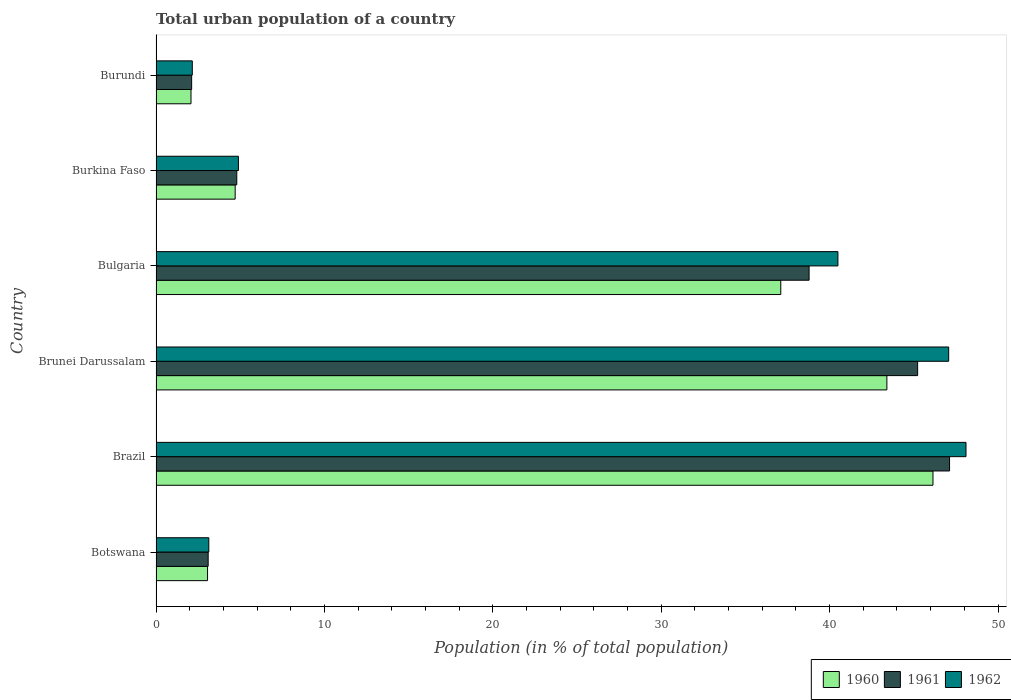Are the number of bars per tick equal to the number of legend labels?
Make the answer very short. Yes. What is the label of the 2nd group of bars from the top?
Provide a short and direct response. Burkina Faso. In how many cases, is the number of bars for a given country not equal to the number of legend labels?
Provide a succinct answer. 0. What is the urban population in 1962 in Burkina Faso?
Keep it short and to the point. 4.89. Across all countries, what is the maximum urban population in 1960?
Ensure brevity in your answer.  46.14. Across all countries, what is the minimum urban population in 1960?
Give a very brief answer. 2.08. In which country was the urban population in 1961 maximum?
Make the answer very short. Brazil. In which country was the urban population in 1960 minimum?
Your answer should be compact. Burundi. What is the total urban population in 1961 in the graph?
Your answer should be compact. 141.14. What is the difference between the urban population in 1962 in Brazil and that in Burkina Faso?
Give a very brief answer. 43.21. What is the difference between the urban population in 1961 in Brunei Darussalam and the urban population in 1960 in Bulgaria?
Your answer should be compact. 8.13. What is the average urban population in 1960 per country?
Offer a very short reply. 22.75. What is the difference between the urban population in 1961 and urban population in 1960 in Brazil?
Offer a very short reply. 0.98. What is the ratio of the urban population in 1960 in Brazil to that in Burkina Faso?
Make the answer very short. 9.82. Is the urban population in 1961 in Bulgaria less than that in Burkina Faso?
Make the answer very short. No. Is the difference between the urban population in 1961 in Brunei Darussalam and Bulgaria greater than the difference between the urban population in 1960 in Brunei Darussalam and Bulgaria?
Offer a very short reply. Yes. What is the difference between the highest and the second highest urban population in 1960?
Offer a very short reply. 2.74. What is the difference between the highest and the lowest urban population in 1961?
Your answer should be very brief. 45.01. In how many countries, is the urban population in 1962 greater than the average urban population in 1962 taken over all countries?
Ensure brevity in your answer.  3. Is it the case that in every country, the sum of the urban population in 1960 and urban population in 1961 is greater than the urban population in 1962?
Your answer should be very brief. Yes. How many bars are there?
Provide a short and direct response. 18. How many countries are there in the graph?
Your answer should be compact. 6. What is the difference between two consecutive major ticks on the X-axis?
Provide a short and direct response. 10. Does the graph contain any zero values?
Your response must be concise. No. Where does the legend appear in the graph?
Your answer should be very brief. Bottom right. How many legend labels are there?
Your response must be concise. 3. How are the legend labels stacked?
Your response must be concise. Horizontal. What is the title of the graph?
Your answer should be very brief. Total urban population of a country. What is the label or title of the X-axis?
Your answer should be very brief. Population (in % of total population). What is the label or title of the Y-axis?
Offer a very short reply. Country. What is the Population (in % of total population) of 1960 in Botswana?
Your answer should be compact. 3.06. What is the Population (in % of total population) in 1961 in Botswana?
Your answer should be very brief. 3.1. What is the Population (in % of total population) in 1962 in Botswana?
Offer a very short reply. 3.13. What is the Population (in % of total population) of 1960 in Brazil?
Provide a short and direct response. 46.14. What is the Population (in % of total population) of 1961 in Brazil?
Your response must be concise. 47.12. What is the Population (in % of total population) of 1962 in Brazil?
Offer a very short reply. 48.1. What is the Population (in % of total population) in 1960 in Brunei Darussalam?
Keep it short and to the point. 43.4. What is the Population (in % of total population) of 1961 in Brunei Darussalam?
Your response must be concise. 45.23. What is the Population (in % of total population) of 1962 in Brunei Darussalam?
Offer a terse response. 47.07. What is the Population (in % of total population) of 1960 in Bulgaria?
Give a very brief answer. 37.1. What is the Population (in % of total population) in 1961 in Bulgaria?
Provide a short and direct response. 38.78. What is the Population (in % of total population) in 1962 in Bulgaria?
Give a very brief answer. 40.49. What is the Population (in % of total population) in 1961 in Burkina Faso?
Make the answer very short. 4.8. What is the Population (in % of total population) of 1962 in Burkina Faso?
Make the answer very short. 4.89. What is the Population (in % of total population) of 1960 in Burundi?
Provide a succinct answer. 2.08. What is the Population (in % of total population) of 1961 in Burundi?
Make the answer very short. 2.12. What is the Population (in % of total population) of 1962 in Burundi?
Offer a terse response. 2.15. Across all countries, what is the maximum Population (in % of total population) of 1960?
Offer a terse response. 46.14. Across all countries, what is the maximum Population (in % of total population) in 1961?
Keep it short and to the point. 47.12. Across all countries, what is the maximum Population (in % of total population) of 1962?
Offer a very short reply. 48.1. Across all countries, what is the minimum Population (in % of total population) in 1960?
Make the answer very short. 2.08. Across all countries, what is the minimum Population (in % of total population) in 1961?
Make the answer very short. 2.12. Across all countries, what is the minimum Population (in % of total population) in 1962?
Offer a terse response. 2.15. What is the total Population (in % of total population) in 1960 in the graph?
Offer a terse response. 136.48. What is the total Population (in % of total population) in 1961 in the graph?
Your answer should be very brief. 141.14. What is the total Population (in % of total population) of 1962 in the graph?
Provide a succinct answer. 145.84. What is the difference between the Population (in % of total population) in 1960 in Botswana and that in Brazil?
Keep it short and to the point. -43.08. What is the difference between the Population (in % of total population) of 1961 in Botswana and that in Brazil?
Ensure brevity in your answer.  -44.02. What is the difference between the Population (in % of total population) in 1962 in Botswana and that in Brazil?
Your answer should be very brief. -44.97. What is the difference between the Population (in % of total population) in 1960 in Botswana and that in Brunei Darussalam?
Give a very brief answer. -40.34. What is the difference between the Population (in % of total population) of 1961 in Botswana and that in Brunei Darussalam?
Your response must be concise. -42.13. What is the difference between the Population (in % of total population) of 1962 in Botswana and that in Brunei Darussalam?
Ensure brevity in your answer.  -43.94. What is the difference between the Population (in % of total population) of 1960 in Botswana and that in Bulgaria?
Offer a very short reply. -34.04. What is the difference between the Population (in % of total population) of 1961 in Botswana and that in Bulgaria?
Provide a short and direct response. -35.69. What is the difference between the Population (in % of total population) of 1962 in Botswana and that in Bulgaria?
Your answer should be compact. -37.36. What is the difference between the Population (in % of total population) in 1960 in Botswana and that in Burkina Faso?
Offer a terse response. -1.64. What is the difference between the Population (in % of total population) of 1961 in Botswana and that in Burkina Faso?
Provide a succinct answer. -1.7. What is the difference between the Population (in % of total population) of 1962 in Botswana and that in Burkina Faso?
Provide a short and direct response. -1.76. What is the difference between the Population (in % of total population) in 1961 in Botswana and that in Burundi?
Provide a short and direct response. 0.98. What is the difference between the Population (in % of total population) of 1960 in Brazil and that in Brunei Darussalam?
Your answer should be compact. 2.74. What is the difference between the Population (in % of total population) of 1961 in Brazil and that in Brunei Darussalam?
Give a very brief answer. 1.89. What is the difference between the Population (in % of total population) in 1960 in Brazil and that in Bulgaria?
Your answer should be compact. 9.04. What is the difference between the Population (in % of total population) of 1961 in Brazil and that in Bulgaria?
Ensure brevity in your answer.  8.34. What is the difference between the Population (in % of total population) in 1962 in Brazil and that in Bulgaria?
Your response must be concise. 7.61. What is the difference between the Population (in % of total population) in 1960 in Brazil and that in Burkina Faso?
Provide a short and direct response. 41.44. What is the difference between the Population (in % of total population) of 1961 in Brazil and that in Burkina Faso?
Offer a terse response. 42.33. What is the difference between the Population (in % of total population) of 1962 in Brazil and that in Burkina Faso?
Make the answer very short. 43.21. What is the difference between the Population (in % of total population) of 1960 in Brazil and that in Burundi?
Provide a succinct answer. 44.06. What is the difference between the Population (in % of total population) of 1961 in Brazil and that in Burundi?
Your response must be concise. 45.01. What is the difference between the Population (in % of total population) in 1962 in Brazil and that in Burundi?
Offer a terse response. 45.95. What is the difference between the Population (in % of total population) in 1960 in Brunei Darussalam and that in Bulgaria?
Make the answer very short. 6.3. What is the difference between the Population (in % of total population) in 1961 in Brunei Darussalam and that in Bulgaria?
Provide a succinct answer. 6.45. What is the difference between the Population (in % of total population) of 1962 in Brunei Darussalam and that in Bulgaria?
Your answer should be very brief. 6.58. What is the difference between the Population (in % of total population) in 1960 in Brunei Darussalam and that in Burkina Faso?
Your answer should be compact. 38.7. What is the difference between the Population (in % of total population) in 1961 in Brunei Darussalam and that in Burkina Faso?
Provide a succinct answer. 40.43. What is the difference between the Population (in % of total population) in 1962 in Brunei Darussalam and that in Burkina Faso?
Your answer should be very brief. 42.18. What is the difference between the Population (in % of total population) of 1960 in Brunei Darussalam and that in Burundi?
Your answer should be compact. 41.32. What is the difference between the Population (in % of total population) in 1961 in Brunei Darussalam and that in Burundi?
Provide a short and direct response. 43.11. What is the difference between the Population (in % of total population) of 1962 in Brunei Darussalam and that in Burundi?
Keep it short and to the point. 44.92. What is the difference between the Population (in % of total population) of 1960 in Bulgaria and that in Burkina Faso?
Keep it short and to the point. 32.4. What is the difference between the Population (in % of total population) in 1961 in Bulgaria and that in Burkina Faso?
Ensure brevity in your answer.  33.99. What is the difference between the Population (in % of total population) of 1962 in Bulgaria and that in Burkina Faso?
Give a very brief answer. 35.6. What is the difference between the Population (in % of total population) in 1960 in Bulgaria and that in Burundi?
Provide a succinct answer. 35.02. What is the difference between the Population (in % of total population) in 1961 in Bulgaria and that in Burundi?
Offer a very short reply. 36.67. What is the difference between the Population (in % of total population) in 1962 in Bulgaria and that in Burundi?
Provide a short and direct response. 38.34. What is the difference between the Population (in % of total population) in 1960 in Burkina Faso and that in Burundi?
Offer a terse response. 2.62. What is the difference between the Population (in % of total population) of 1961 in Burkina Faso and that in Burundi?
Your response must be concise. 2.68. What is the difference between the Population (in % of total population) of 1962 in Burkina Faso and that in Burundi?
Give a very brief answer. 2.74. What is the difference between the Population (in % of total population) in 1960 in Botswana and the Population (in % of total population) in 1961 in Brazil?
Your answer should be compact. -44.06. What is the difference between the Population (in % of total population) in 1960 in Botswana and the Population (in % of total population) in 1962 in Brazil?
Your response must be concise. -45.04. What is the difference between the Population (in % of total population) in 1961 in Botswana and the Population (in % of total population) in 1962 in Brazil?
Give a very brief answer. -45. What is the difference between the Population (in % of total population) of 1960 in Botswana and the Population (in % of total population) of 1961 in Brunei Darussalam?
Offer a very short reply. -42.17. What is the difference between the Population (in % of total population) in 1960 in Botswana and the Population (in % of total population) in 1962 in Brunei Darussalam?
Keep it short and to the point. -44.01. What is the difference between the Population (in % of total population) of 1961 in Botswana and the Population (in % of total population) of 1962 in Brunei Darussalam?
Keep it short and to the point. -43.97. What is the difference between the Population (in % of total population) of 1960 in Botswana and the Population (in % of total population) of 1961 in Bulgaria?
Ensure brevity in your answer.  -35.72. What is the difference between the Population (in % of total population) in 1960 in Botswana and the Population (in % of total population) in 1962 in Bulgaria?
Your answer should be very brief. -37.43. What is the difference between the Population (in % of total population) of 1961 in Botswana and the Population (in % of total population) of 1962 in Bulgaria?
Provide a succinct answer. -37.4. What is the difference between the Population (in % of total population) of 1960 in Botswana and the Population (in % of total population) of 1961 in Burkina Faso?
Your answer should be very brief. -1.74. What is the difference between the Population (in % of total population) of 1960 in Botswana and the Population (in % of total population) of 1962 in Burkina Faso?
Make the answer very short. -1.83. What is the difference between the Population (in % of total population) in 1961 in Botswana and the Population (in % of total population) in 1962 in Burkina Faso?
Your answer should be compact. -1.8. What is the difference between the Population (in % of total population) of 1960 in Botswana and the Population (in % of total population) of 1961 in Burundi?
Provide a succinct answer. 0.94. What is the difference between the Population (in % of total population) of 1960 in Botswana and the Population (in % of total population) of 1962 in Burundi?
Your response must be concise. 0.91. What is the difference between the Population (in % of total population) of 1961 in Botswana and the Population (in % of total population) of 1962 in Burundi?
Your answer should be compact. 0.94. What is the difference between the Population (in % of total population) in 1960 in Brazil and the Population (in % of total population) in 1961 in Brunei Darussalam?
Provide a short and direct response. 0.91. What is the difference between the Population (in % of total population) of 1960 in Brazil and the Population (in % of total population) of 1962 in Brunei Darussalam?
Keep it short and to the point. -0.93. What is the difference between the Population (in % of total population) in 1961 in Brazil and the Population (in % of total population) in 1962 in Brunei Darussalam?
Provide a succinct answer. 0.05. What is the difference between the Population (in % of total population) of 1960 in Brazil and the Population (in % of total population) of 1961 in Bulgaria?
Ensure brevity in your answer.  7.36. What is the difference between the Population (in % of total population) in 1960 in Brazil and the Population (in % of total population) in 1962 in Bulgaria?
Offer a terse response. 5.64. What is the difference between the Population (in % of total population) of 1961 in Brazil and the Population (in % of total population) of 1962 in Bulgaria?
Keep it short and to the point. 6.63. What is the difference between the Population (in % of total population) in 1960 in Brazil and the Population (in % of total population) in 1961 in Burkina Faso?
Keep it short and to the point. 41.34. What is the difference between the Population (in % of total population) of 1960 in Brazil and the Population (in % of total population) of 1962 in Burkina Faso?
Make the answer very short. 41.25. What is the difference between the Population (in % of total population) in 1961 in Brazil and the Population (in % of total population) in 1962 in Burkina Faso?
Your answer should be compact. 42.23. What is the difference between the Population (in % of total population) in 1960 in Brazil and the Population (in % of total population) in 1961 in Burundi?
Offer a terse response. 44.02. What is the difference between the Population (in % of total population) in 1960 in Brazil and the Population (in % of total population) in 1962 in Burundi?
Your answer should be compact. 43.98. What is the difference between the Population (in % of total population) in 1961 in Brazil and the Population (in % of total population) in 1962 in Burundi?
Offer a very short reply. 44.97. What is the difference between the Population (in % of total population) in 1960 in Brunei Darussalam and the Population (in % of total population) in 1961 in Bulgaria?
Your answer should be very brief. 4.62. What is the difference between the Population (in % of total population) in 1960 in Brunei Darussalam and the Population (in % of total population) in 1962 in Bulgaria?
Provide a short and direct response. 2.91. What is the difference between the Population (in % of total population) of 1961 in Brunei Darussalam and the Population (in % of total population) of 1962 in Bulgaria?
Give a very brief answer. 4.73. What is the difference between the Population (in % of total population) of 1960 in Brunei Darussalam and the Population (in % of total population) of 1961 in Burkina Faso?
Give a very brief answer. 38.6. What is the difference between the Population (in % of total population) in 1960 in Brunei Darussalam and the Population (in % of total population) in 1962 in Burkina Faso?
Offer a very short reply. 38.51. What is the difference between the Population (in % of total population) of 1961 in Brunei Darussalam and the Population (in % of total population) of 1962 in Burkina Faso?
Your answer should be very brief. 40.34. What is the difference between the Population (in % of total population) in 1960 in Brunei Darussalam and the Population (in % of total population) in 1961 in Burundi?
Your response must be concise. 41.29. What is the difference between the Population (in % of total population) of 1960 in Brunei Darussalam and the Population (in % of total population) of 1962 in Burundi?
Your answer should be compact. 41.25. What is the difference between the Population (in % of total population) in 1961 in Brunei Darussalam and the Population (in % of total population) in 1962 in Burundi?
Ensure brevity in your answer.  43.07. What is the difference between the Population (in % of total population) in 1960 in Bulgaria and the Population (in % of total population) in 1961 in Burkina Faso?
Ensure brevity in your answer.  32.3. What is the difference between the Population (in % of total population) in 1960 in Bulgaria and the Population (in % of total population) in 1962 in Burkina Faso?
Your response must be concise. 32.21. What is the difference between the Population (in % of total population) in 1961 in Bulgaria and the Population (in % of total population) in 1962 in Burkina Faso?
Make the answer very short. 33.89. What is the difference between the Population (in % of total population) of 1960 in Bulgaria and the Population (in % of total population) of 1961 in Burundi?
Offer a very short reply. 34.98. What is the difference between the Population (in % of total population) in 1960 in Bulgaria and the Population (in % of total population) in 1962 in Burundi?
Provide a short and direct response. 34.95. What is the difference between the Population (in % of total population) in 1961 in Bulgaria and the Population (in % of total population) in 1962 in Burundi?
Give a very brief answer. 36.63. What is the difference between the Population (in % of total population) of 1960 in Burkina Faso and the Population (in % of total population) of 1961 in Burundi?
Provide a succinct answer. 2.58. What is the difference between the Population (in % of total population) in 1960 in Burkina Faso and the Population (in % of total population) in 1962 in Burundi?
Offer a terse response. 2.55. What is the difference between the Population (in % of total population) of 1961 in Burkina Faso and the Population (in % of total population) of 1962 in Burundi?
Offer a terse response. 2.64. What is the average Population (in % of total population) of 1960 per country?
Keep it short and to the point. 22.75. What is the average Population (in % of total population) of 1961 per country?
Your answer should be very brief. 23.52. What is the average Population (in % of total population) of 1962 per country?
Keep it short and to the point. 24.31. What is the difference between the Population (in % of total population) of 1960 and Population (in % of total population) of 1961 in Botswana?
Make the answer very short. -0.04. What is the difference between the Population (in % of total population) of 1960 and Population (in % of total population) of 1962 in Botswana?
Make the answer very short. -0.07. What is the difference between the Population (in % of total population) of 1961 and Population (in % of total population) of 1962 in Botswana?
Offer a terse response. -0.04. What is the difference between the Population (in % of total population) of 1960 and Population (in % of total population) of 1961 in Brazil?
Make the answer very short. -0.98. What is the difference between the Population (in % of total population) in 1960 and Population (in % of total population) in 1962 in Brazil?
Your response must be concise. -1.96. What is the difference between the Population (in % of total population) in 1961 and Population (in % of total population) in 1962 in Brazil?
Offer a very short reply. -0.98. What is the difference between the Population (in % of total population) in 1960 and Population (in % of total population) in 1961 in Brunei Darussalam?
Provide a short and direct response. -1.83. What is the difference between the Population (in % of total population) in 1960 and Population (in % of total population) in 1962 in Brunei Darussalam?
Provide a short and direct response. -3.67. What is the difference between the Population (in % of total population) in 1961 and Population (in % of total population) in 1962 in Brunei Darussalam?
Your response must be concise. -1.84. What is the difference between the Population (in % of total population) of 1960 and Population (in % of total population) of 1961 in Bulgaria?
Offer a terse response. -1.68. What is the difference between the Population (in % of total population) of 1960 and Population (in % of total population) of 1962 in Bulgaria?
Keep it short and to the point. -3.39. What is the difference between the Population (in % of total population) in 1961 and Population (in % of total population) in 1962 in Bulgaria?
Make the answer very short. -1.71. What is the difference between the Population (in % of total population) of 1960 and Population (in % of total population) of 1961 in Burkina Faso?
Provide a succinct answer. -0.1. What is the difference between the Population (in % of total population) of 1960 and Population (in % of total population) of 1962 in Burkina Faso?
Your answer should be compact. -0.19. What is the difference between the Population (in % of total population) of 1961 and Population (in % of total population) of 1962 in Burkina Faso?
Your answer should be compact. -0.1. What is the difference between the Population (in % of total population) in 1960 and Population (in % of total population) in 1961 in Burundi?
Your answer should be very brief. -0.04. What is the difference between the Population (in % of total population) of 1960 and Population (in % of total population) of 1962 in Burundi?
Give a very brief answer. -0.08. What is the difference between the Population (in % of total population) of 1961 and Population (in % of total population) of 1962 in Burundi?
Your answer should be compact. -0.04. What is the ratio of the Population (in % of total population) of 1960 in Botswana to that in Brazil?
Keep it short and to the point. 0.07. What is the ratio of the Population (in % of total population) in 1961 in Botswana to that in Brazil?
Keep it short and to the point. 0.07. What is the ratio of the Population (in % of total population) of 1962 in Botswana to that in Brazil?
Give a very brief answer. 0.07. What is the ratio of the Population (in % of total population) in 1960 in Botswana to that in Brunei Darussalam?
Your answer should be very brief. 0.07. What is the ratio of the Population (in % of total population) in 1961 in Botswana to that in Brunei Darussalam?
Offer a very short reply. 0.07. What is the ratio of the Population (in % of total population) of 1962 in Botswana to that in Brunei Darussalam?
Provide a succinct answer. 0.07. What is the ratio of the Population (in % of total population) in 1960 in Botswana to that in Bulgaria?
Ensure brevity in your answer.  0.08. What is the ratio of the Population (in % of total population) in 1961 in Botswana to that in Bulgaria?
Provide a succinct answer. 0.08. What is the ratio of the Population (in % of total population) in 1962 in Botswana to that in Bulgaria?
Your answer should be compact. 0.08. What is the ratio of the Population (in % of total population) of 1960 in Botswana to that in Burkina Faso?
Offer a terse response. 0.65. What is the ratio of the Population (in % of total population) of 1961 in Botswana to that in Burkina Faso?
Keep it short and to the point. 0.65. What is the ratio of the Population (in % of total population) in 1962 in Botswana to that in Burkina Faso?
Your answer should be very brief. 0.64. What is the ratio of the Population (in % of total population) in 1960 in Botswana to that in Burundi?
Offer a terse response. 1.47. What is the ratio of the Population (in % of total population) in 1961 in Botswana to that in Burundi?
Your answer should be compact. 1.46. What is the ratio of the Population (in % of total population) in 1962 in Botswana to that in Burundi?
Your answer should be very brief. 1.46. What is the ratio of the Population (in % of total population) of 1960 in Brazil to that in Brunei Darussalam?
Your answer should be compact. 1.06. What is the ratio of the Population (in % of total population) of 1961 in Brazil to that in Brunei Darussalam?
Your answer should be compact. 1.04. What is the ratio of the Population (in % of total population) in 1962 in Brazil to that in Brunei Darussalam?
Keep it short and to the point. 1.02. What is the ratio of the Population (in % of total population) in 1960 in Brazil to that in Bulgaria?
Offer a very short reply. 1.24. What is the ratio of the Population (in % of total population) in 1961 in Brazil to that in Bulgaria?
Make the answer very short. 1.22. What is the ratio of the Population (in % of total population) in 1962 in Brazil to that in Bulgaria?
Ensure brevity in your answer.  1.19. What is the ratio of the Population (in % of total population) of 1960 in Brazil to that in Burkina Faso?
Make the answer very short. 9.82. What is the ratio of the Population (in % of total population) in 1961 in Brazil to that in Burkina Faso?
Your response must be concise. 9.83. What is the ratio of the Population (in % of total population) of 1962 in Brazil to that in Burkina Faso?
Your answer should be very brief. 9.83. What is the ratio of the Population (in % of total population) of 1960 in Brazil to that in Burundi?
Keep it short and to the point. 22.21. What is the ratio of the Population (in % of total population) of 1961 in Brazil to that in Burundi?
Keep it short and to the point. 22.28. What is the ratio of the Population (in % of total population) in 1962 in Brazil to that in Burundi?
Offer a terse response. 22.33. What is the ratio of the Population (in % of total population) of 1960 in Brunei Darussalam to that in Bulgaria?
Your response must be concise. 1.17. What is the ratio of the Population (in % of total population) in 1961 in Brunei Darussalam to that in Bulgaria?
Your response must be concise. 1.17. What is the ratio of the Population (in % of total population) of 1962 in Brunei Darussalam to that in Bulgaria?
Your answer should be very brief. 1.16. What is the ratio of the Population (in % of total population) of 1960 in Brunei Darussalam to that in Burkina Faso?
Provide a succinct answer. 9.23. What is the ratio of the Population (in % of total population) of 1961 in Brunei Darussalam to that in Burkina Faso?
Offer a terse response. 9.43. What is the ratio of the Population (in % of total population) in 1962 in Brunei Darussalam to that in Burkina Faso?
Your answer should be compact. 9.62. What is the ratio of the Population (in % of total population) of 1960 in Brunei Darussalam to that in Burundi?
Ensure brevity in your answer.  20.9. What is the ratio of the Population (in % of total population) of 1961 in Brunei Darussalam to that in Burundi?
Your response must be concise. 21.38. What is the ratio of the Population (in % of total population) in 1962 in Brunei Darussalam to that in Burundi?
Your answer should be very brief. 21.85. What is the ratio of the Population (in % of total population) of 1960 in Bulgaria to that in Burkina Faso?
Your response must be concise. 7.89. What is the ratio of the Population (in % of total population) in 1961 in Bulgaria to that in Burkina Faso?
Offer a terse response. 8.09. What is the ratio of the Population (in % of total population) of 1962 in Bulgaria to that in Burkina Faso?
Give a very brief answer. 8.28. What is the ratio of the Population (in % of total population) in 1960 in Bulgaria to that in Burundi?
Ensure brevity in your answer.  17.86. What is the ratio of the Population (in % of total population) in 1961 in Bulgaria to that in Burundi?
Offer a terse response. 18.34. What is the ratio of the Population (in % of total population) of 1962 in Bulgaria to that in Burundi?
Keep it short and to the point. 18.8. What is the ratio of the Population (in % of total population) in 1960 in Burkina Faso to that in Burundi?
Keep it short and to the point. 2.26. What is the ratio of the Population (in % of total population) in 1961 in Burkina Faso to that in Burundi?
Your answer should be compact. 2.27. What is the ratio of the Population (in % of total population) in 1962 in Burkina Faso to that in Burundi?
Make the answer very short. 2.27. What is the difference between the highest and the second highest Population (in % of total population) of 1960?
Provide a short and direct response. 2.74. What is the difference between the highest and the second highest Population (in % of total population) in 1961?
Your answer should be very brief. 1.89. What is the difference between the highest and the lowest Population (in % of total population) of 1960?
Ensure brevity in your answer.  44.06. What is the difference between the highest and the lowest Population (in % of total population) in 1961?
Offer a terse response. 45.01. What is the difference between the highest and the lowest Population (in % of total population) in 1962?
Your response must be concise. 45.95. 